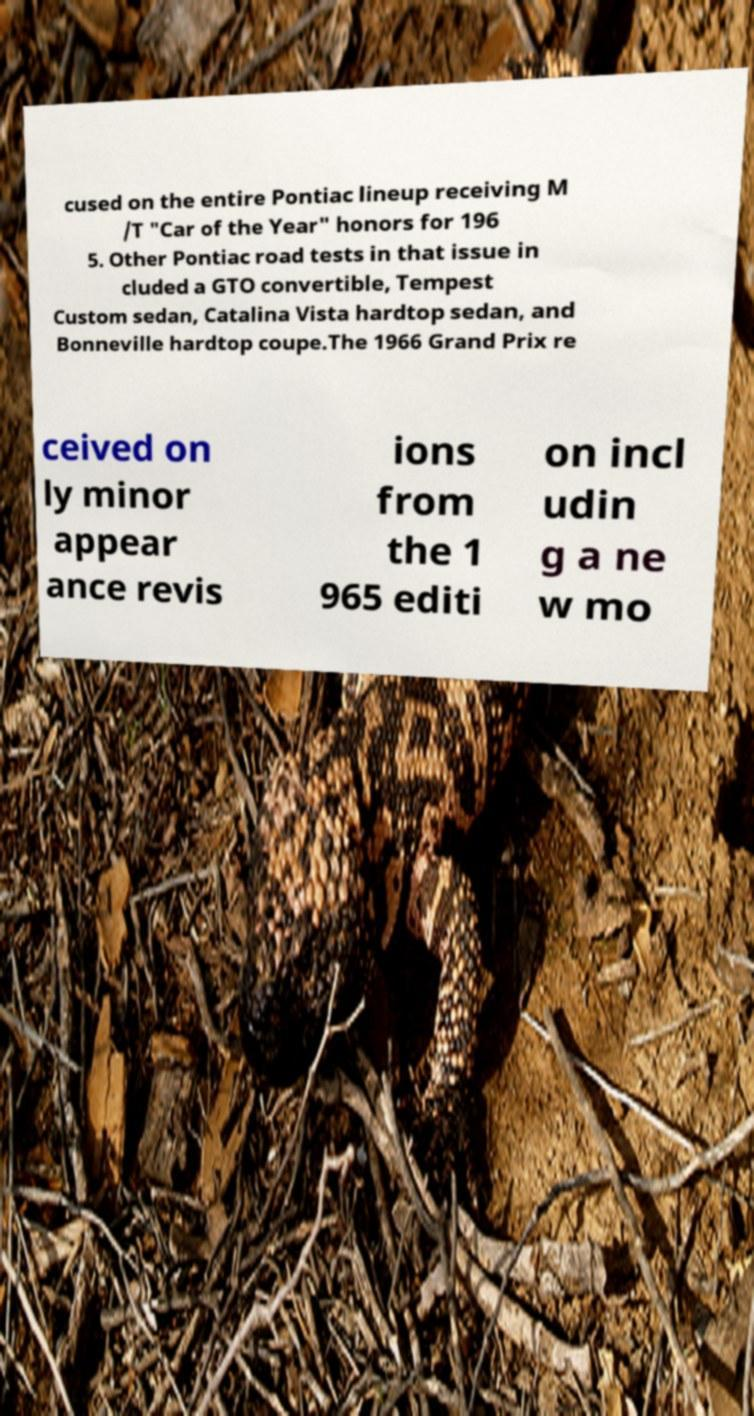For documentation purposes, I need the text within this image transcribed. Could you provide that? cused on the entire Pontiac lineup receiving M /T "Car of the Year" honors for 196 5. Other Pontiac road tests in that issue in cluded a GTO convertible, Tempest Custom sedan, Catalina Vista hardtop sedan, and Bonneville hardtop coupe.The 1966 Grand Prix re ceived on ly minor appear ance revis ions from the 1 965 editi on incl udin g a ne w mo 